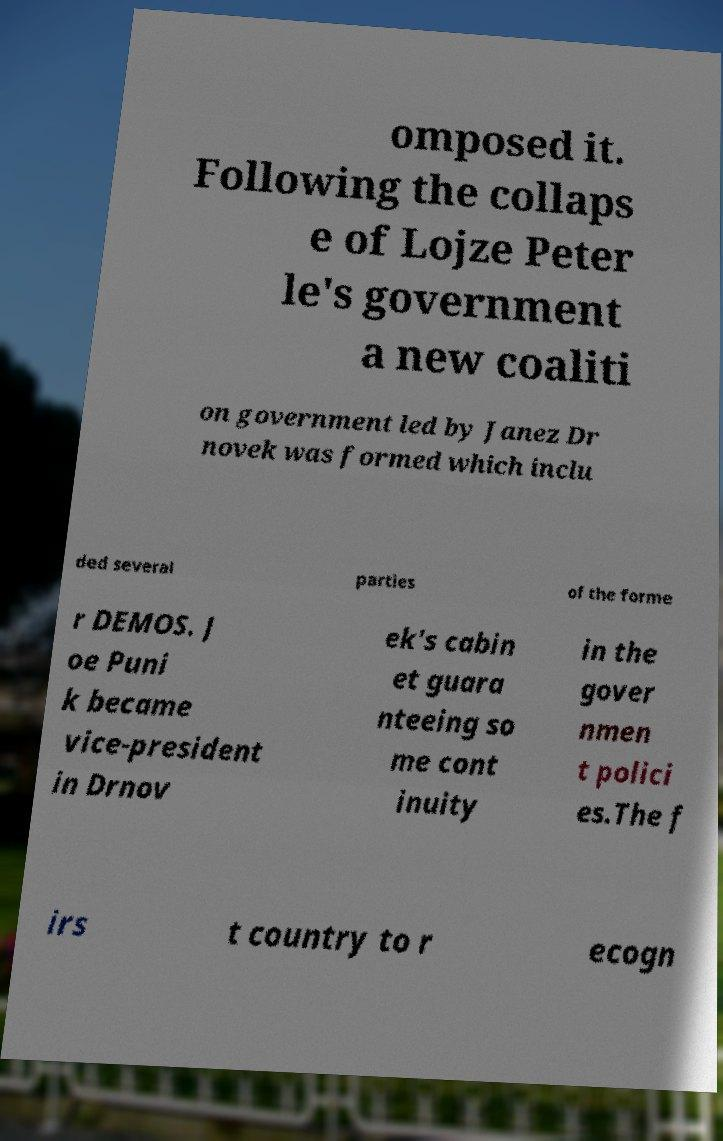Can you accurately transcribe the text from the provided image for me? omposed it. Following the collaps e of Lojze Peter le's government a new coaliti on government led by Janez Dr novek was formed which inclu ded several parties of the forme r DEMOS. J oe Puni k became vice-president in Drnov ek's cabin et guara nteeing so me cont inuity in the gover nmen t polici es.The f irs t country to r ecogn 